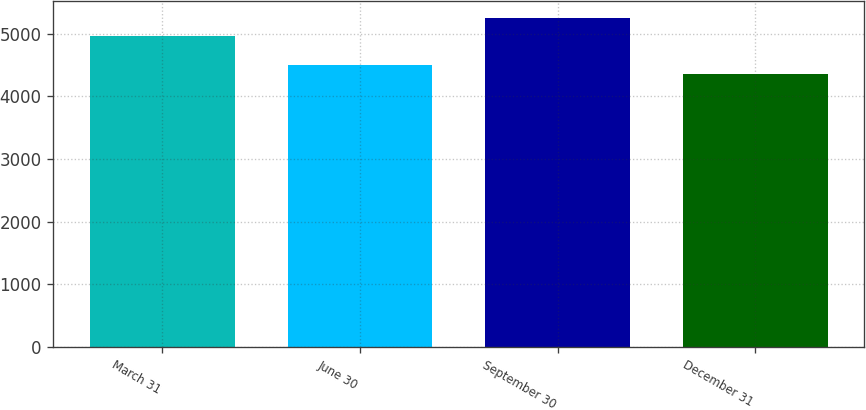<chart> <loc_0><loc_0><loc_500><loc_500><bar_chart><fcel>March 31<fcel>June 30<fcel>September 30<fcel>December 31<nl><fcel>4956<fcel>4496<fcel>5254<fcel>4357<nl></chart> 